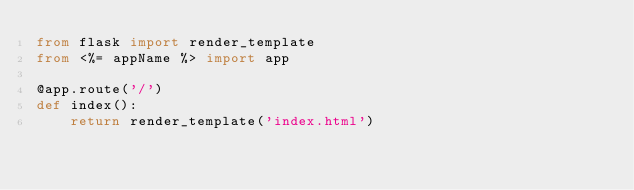Convert code to text. <code><loc_0><loc_0><loc_500><loc_500><_Python_>from flask import render_template
from <%= appName %> import app 

@app.route('/')
def index():
    return render_template('index.html')
</code> 